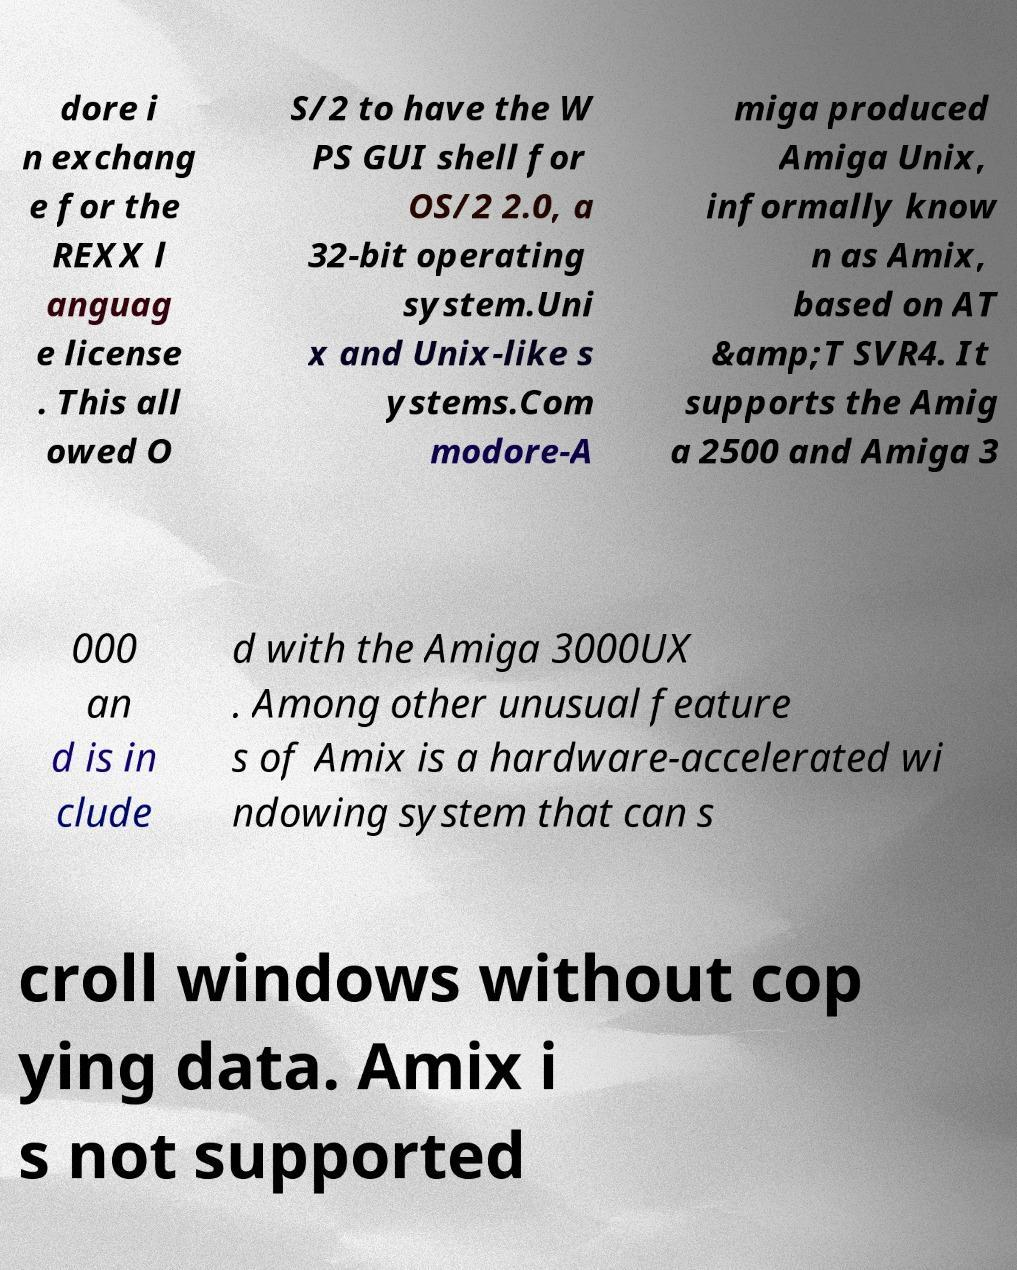I need the written content from this picture converted into text. Can you do that? dore i n exchang e for the REXX l anguag e license . This all owed O S/2 to have the W PS GUI shell for OS/2 2.0, a 32-bit operating system.Uni x and Unix-like s ystems.Com modore-A miga produced Amiga Unix, informally know n as Amix, based on AT &amp;T SVR4. It supports the Amig a 2500 and Amiga 3 000 an d is in clude d with the Amiga 3000UX . Among other unusual feature s of Amix is a hardware-accelerated wi ndowing system that can s croll windows without cop ying data. Amix i s not supported 